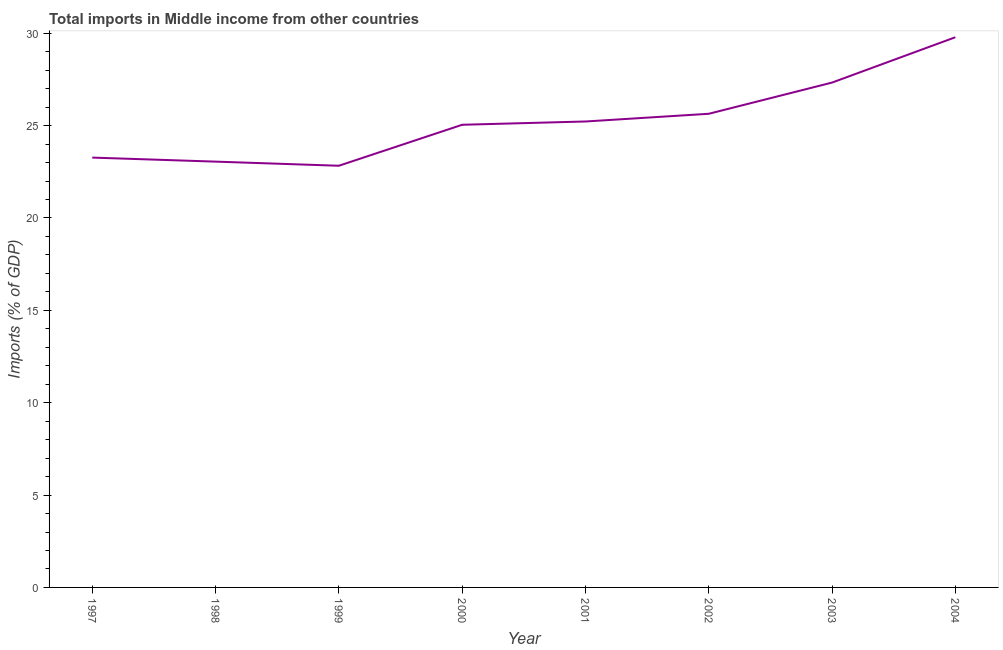What is the total imports in 2000?
Provide a short and direct response. 25.04. Across all years, what is the maximum total imports?
Provide a succinct answer. 29.78. Across all years, what is the minimum total imports?
Keep it short and to the point. 22.83. What is the sum of the total imports?
Provide a succinct answer. 202.16. What is the difference between the total imports in 1997 and 2002?
Provide a short and direct response. -2.37. What is the average total imports per year?
Give a very brief answer. 25.27. What is the median total imports?
Give a very brief answer. 25.13. Do a majority of the years between 1998 and 1999 (inclusive) have total imports greater than 8 %?
Ensure brevity in your answer.  Yes. What is the ratio of the total imports in 1999 to that in 2003?
Provide a succinct answer. 0.84. Is the difference between the total imports in 2001 and 2003 greater than the difference between any two years?
Offer a very short reply. No. What is the difference between the highest and the second highest total imports?
Ensure brevity in your answer.  2.45. Is the sum of the total imports in 1998 and 2004 greater than the maximum total imports across all years?
Your answer should be very brief. Yes. What is the difference between the highest and the lowest total imports?
Provide a succinct answer. 6.96. Does the graph contain any zero values?
Your answer should be compact. No. What is the title of the graph?
Provide a short and direct response. Total imports in Middle income from other countries. What is the label or title of the X-axis?
Provide a short and direct response. Year. What is the label or title of the Y-axis?
Keep it short and to the point. Imports (% of GDP). What is the Imports (% of GDP) of 1997?
Offer a very short reply. 23.27. What is the Imports (% of GDP) in 1998?
Your answer should be compact. 23.05. What is the Imports (% of GDP) of 1999?
Your answer should be compact. 22.83. What is the Imports (% of GDP) of 2000?
Provide a short and direct response. 25.04. What is the Imports (% of GDP) of 2001?
Give a very brief answer. 25.22. What is the Imports (% of GDP) of 2002?
Offer a terse response. 25.64. What is the Imports (% of GDP) in 2003?
Provide a succinct answer. 27.33. What is the Imports (% of GDP) in 2004?
Provide a short and direct response. 29.78. What is the difference between the Imports (% of GDP) in 1997 and 1998?
Your answer should be compact. 0.22. What is the difference between the Imports (% of GDP) in 1997 and 1999?
Ensure brevity in your answer.  0.44. What is the difference between the Imports (% of GDP) in 1997 and 2000?
Make the answer very short. -1.78. What is the difference between the Imports (% of GDP) in 1997 and 2001?
Your answer should be compact. -1.95. What is the difference between the Imports (% of GDP) in 1997 and 2002?
Your response must be concise. -2.37. What is the difference between the Imports (% of GDP) in 1997 and 2003?
Offer a very short reply. -4.06. What is the difference between the Imports (% of GDP) in 1997 and 2004?
Your answer should be very brief. -6.51. What is the difference between the Imports (% of GDP) in 1998 and 1999?
Ensure brevity in your answer.  0.22. What is the difference between the Imports (% of GDP) in 1998 and 2000?
Give a very brief answer. -1.99. What is the difference between the Imports (% of GDP) in 1998 and 2001?
Your answer should be very brief. -2.17. What is the difference between the Imports (% of GDP) in 1998 and 2002?
Ensure brevity in your answer.  -2.59. What is the difference between the Imports (% of GDP) in 1998 and 2003?
Ensure brevity in your answer.  -4.28. What is the difference between the Imports (% of GDP) in 1998 and 2004?
Offer a very short reply. -6.73. What is the difference between the Imports (% of GDP) in 1999 and 2000?
Provide a short and direct response. -2.22. What is the difference between the Imports (% of GDP) in 1999 and 2001?
Give a very brief answer. -2.4. What is the difference between the Imports (% of GDP) in 1999 and 2002?
Your response must be concise. -2.81. What is the difference between the Imports (% of GDP) in 1999 and 2003?
Your response must be concise. -4.5. What is the difference between the Imports (% of GDP) in 1999 and 2004?
Keep it short and to the point. -6.96. What is the difference between the Imports (% of GDP) in 2000 and 2001?
Your response must be concise. -0.18. What is the difference between the Imports (% of GDP) in 2000 and 2002?
Your response must be concise. -0.59. What is the difference between the Imports (% of GDP) in 2000 and 2003?
Keep it short and to the point. -2.28. What is the difference between the Imports (% of GDP) in 2000 and 2004?
Your response must be concise. -4.74. What is the difference between the Imports (% of GDP) in 2001 and 2002?
Ensure brevity in your answer.  -0.42. What is the difference between the Imports (% of GDP) in 2001 and 2003?
Provide a short and direct response. -2.11. What is the difference between the Imports (% of GDP) in 2001 and 2004?
Give a very brief answer. -4.56. What is the difference between the Imports (% of GDP) in 2002 and 2003?
Provide a short and direct response. -1.69. What is the difference between the Imports (% of GDP) in 2002 and 2004?
Your answer should be compact. -4.14. What is the difference between the Imports (% of GDP) in 2003 and 2004?
Ensure brevity in your answer.  -2.45. What is the ratio of the Imports (% of GDP) in 1997 to that in 2000?
Ensure brevity in your answer.  0.93. What is the ratio of the Imports (% of GDP) in 1997 to that in 2001?
Give a very brief answer. 0.92. What is the ratio of the Imports (% of GDP) in 1997 to that in 2002?
Keep it short and to the point. 0.91. What is the ratio of the Imports (% of GDP) in 1997 to that in 2003?
Offer a very short reply. 0.85. What is the ratio of the Imports (% of GDP) in 1997 to that in 2004?
Ensure brevity in your answer.  0.78. What is the ratio of the Imports (% of GDP) in 1998 to that in 2001?
Your response must be concise. 0.91. What is the ratio of the Imports (% of GDP) in 1998 to that in 2002?
Ensure brevity in your answer.  0.9. What is the ratio of the Imports (% of GDP) in 1998 to that in 2003?
Offer a terse response. 0.84. What is the ratio of the Imports (% of GDP) in 1998 to that in 2004?
Keep it short and to the point. 0.77. What is the ratio of the Imports (% of GDP) in 1999 to that in 2000?
Give a very brief answer. 0.91. What is the ratio of the Imports (% of GDP) in 1999 to that in 2001?
Keep it short and to the point. 0.91. What is the ratio of the Imports (% of GDP) in 1999 to that in 2002?
Give a very brief answer. 0.89. What is the ratio of the Imports (% of GDP) in 1999 to that in 2003?
Give a very brief answer. 0.83. What is the ratio of the Imports (% of GDP) in 1999 to that in 2004?
Ensure brevity in your answer.  0.77. What is the ratio of the Imports (% of GDP) in 2000 to that in 2001?
Your answer should be compact. 0.99. What is the ratio of the Imports (% of GDP) in 2000 to that in 2002?
Your answer should be compact. 0.98. What is the ratio of the Imports (% of GDP) in 2000 to that in 2003?
Offer a terse response. 0.92. What is the ratio of the Imports (% of GDP) in 2000 to that in 2004?
Your response must be concise. 0.84. What is the ratio of the Imports (% of GDP) in 2001 to that in 2002?
Keep it short and to the point. 0.98. What is the ratio of the Imports (% of GDP) in 2001 to that in 2003?
Your response must be concise. 0.92. What is the ratio of the Imports (% of GDP) in 2001 to that in 2004?
Your answer should be very brief. 0.85. What is the ratio of the Imports (% of GDP) in 2002 to that in 2003?
Offer a terse response. 0.94. What is the ratio of the Imports (% of GDP) in 2002 to that in 2004?
Make the answer very short. 0.86. What is the ratio of the Imports (% of GDP) in 2003 to that in 2004?
Your answer should be very brief. 0.92. 